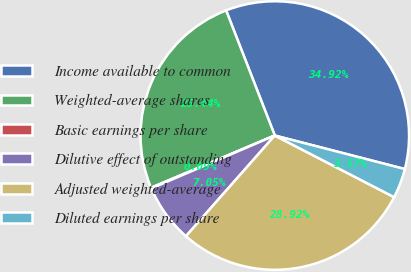<chart> <loc_0><loc_0><loc_500><loc_500><pie_chart><fcel>Income available to common<fcel>Weighted-average shares<fcel>Basic earnings per share<fcel>Dilutive effect of outstanding<fcel>Adjusted weighted-average<fcel>Diluted earnings per share<nl><fcel>34.92%<fcel>25.44%<fcel>0.09%<fcel>7.05%<fcel>28.92%<fcel>3.57%<nl></chart> 